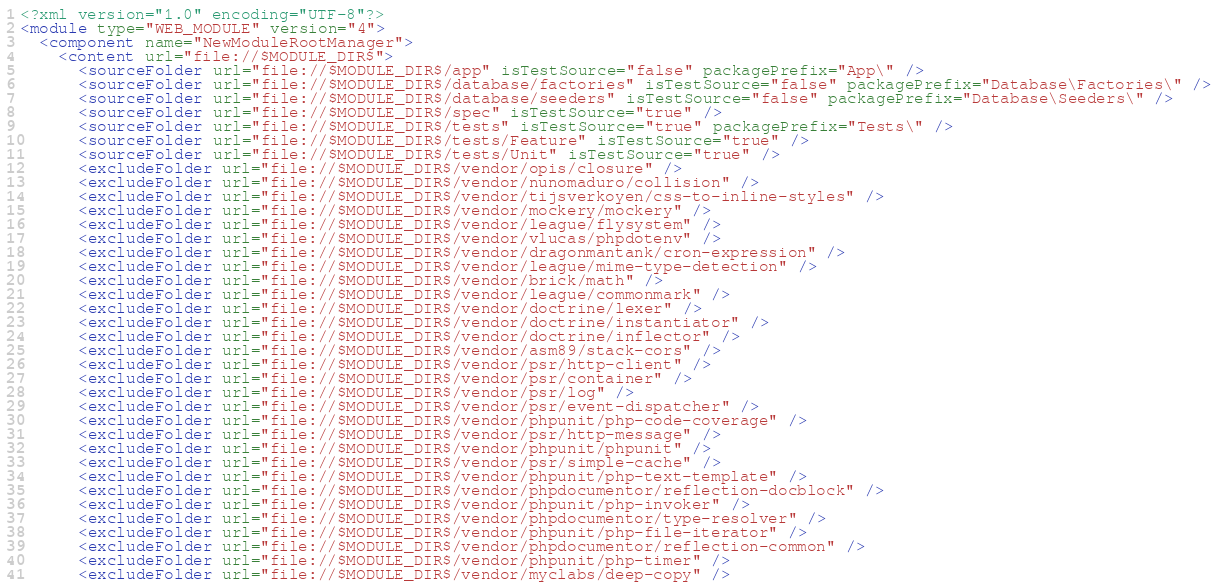Convert code to text. <code><loc_0><loc_0><loc_500><loc_500><_XML_><?xml version="1.0" encoding="UTF-8"?>
<module type="WEB_MODULE" version="4">
  <component name="NewModuleRootManager">
    <content url="file://$MODULE_DIR$">
      <sourceFolder url="file://$MODULE_DIR$/app" isTestSource="false" packagePrefix="App\" />
      <sourceFolder url="file://$MODULE_DIR$/database/factories" isTestSource="false" packagePrefix="Database\Factories\" />
      <sourceFolder url="file://$MODULE_DIR$/database/seeders" isTestSource="false" packagePrefix="Database\Seeders\" />
      <sourceFolder url="file://$MODULE_DIR$/spec" isTestSource="true" />
      <sourceFolder url="file://$MODULE_DIR$/tests" isTestSource="true" packagePrefix="Tests\" />
      <sourceFolder url="file://$MODULE_DIR$/tests/Feature" isTestSource="true" />
      <sourceFolder url="file://$MODULE_DIR$/tests/Unit" isTestSource="true" />
      <excludeFolder url="file://$MODULE_DIR$/vendor/opis/closure" />
      <excludeFolder url="file://$MODULE_DIR$/vendor/nunomaduro/collision" />
      <excludeFolder url="file://$MODULE_DIR$/vendor/tijsverkoyen/css-to-inline-styles" />
      <excludeFolder url="file://$MODULE_DIR$/vendor/mockery/mockery" />
      <excludeFolder url="file://$MODULE_DIR$/vendor/league/flysystem" />
      <excludeFolder url="file://$MODULE_DIR$/vendor/vlucas/phpdotenv" />
      <excludeFolder url="file://$MODULE_DIR$/vendor/dragonmantank/cron-expression" />
      <excludeFolder url="file://$MODULE_DIR$/vendor/league/mime-type-detection" />
      <excludeFolder url="file://$MODULE_DIR$/vendor/brick/math" />
      <excludeFolder url="file://$MODULE_DIR$/vendor/league/commonmark" />
      <excludeFolder url="file://$MODULE_DIR$/vendor/doctrine/lexer" />
      <excludeFolder url="file://$MODULE_DIR$/vendor/doctrine/instantiator" />
      <excludeFolder url="file://$MODULE_DIR$/vendor/doctrine/inflector" />
      <excludeFolder url="file://$MODULE_DIR$/vendor/asm89/stack-cors" />
      <excludeFolder url="file://$MODULE_DIR$/vendor/psr/http-client" />
      <excludeFolder url="file://$MODULE_DIR$/vendor/psr/container" />
      <excludeFolder url="file://$MODULE_DIR$/vendor/psr/log" />
      <excludeFolder url="file://$MODULE_DIR$/vendor/psr/event-dispatcher" />
      <excludeFolder url="file://$MODULE_DIR$/vendor/phpunit/php-code-coverage" />
      <excludeFolder url="file://$MODULE_DIR$/vendor/psr/http-message" />
      <excludeFolder url="file://$MODULE_DIR$/vendor/phpunit/phpunit" />
      <excludeFolder url="file://$MODULE_DIR$/vendor/psr/simple-cache" />
      <excludeFolder url="file://$MODULE_DIR$/vendor/phpunit/php-text-template" />
      <excludeFolder url="file://$MODULE_DIR$/vendor/phpdocumentor/reflection-docblock" />
      <excludeFolder url="file://$MODULE_DIR$/vendor/phpunit/php-invoker" />
      <excludeFolder url="file://$MODULE_DIR$/vendor/phpdocumentor/type-resolver" />
      <excludeFolder url="file://$MODULE_DIR$/vendor/phpunit/php-file-iterator" />
      <excludeFolder url="file://$MODULE_DIR$/vendor/phpdocumentor/reflection-common" />
      <excludeFolder url="file://$MODULE_DIR$/vendor/phpunit/php-timer" />
      <excludeFolder url="file://$MODULE_DIR$/vendor/myclabs/deep-copy" /></code> 